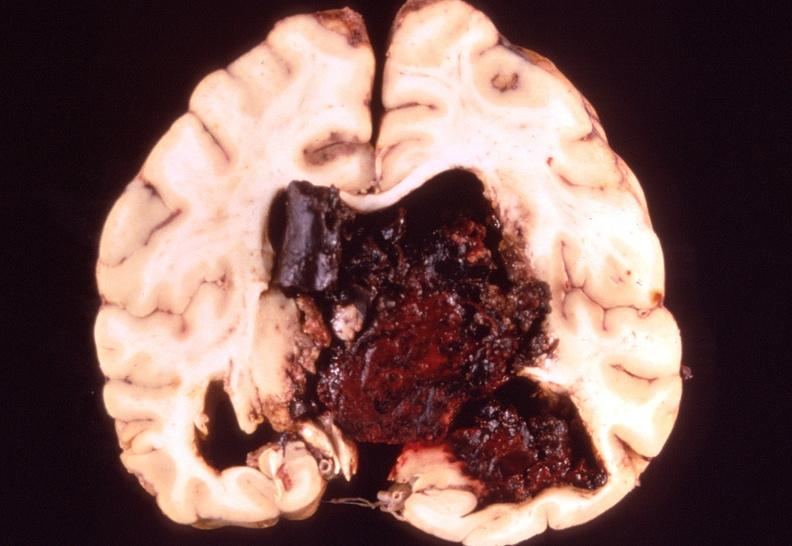s nervous present?
Answer the question using a single word or phrase. Yes 